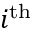<formula> <loc_0><loc_0><loc_500><loc_500>i ^ { t h }</formula> 